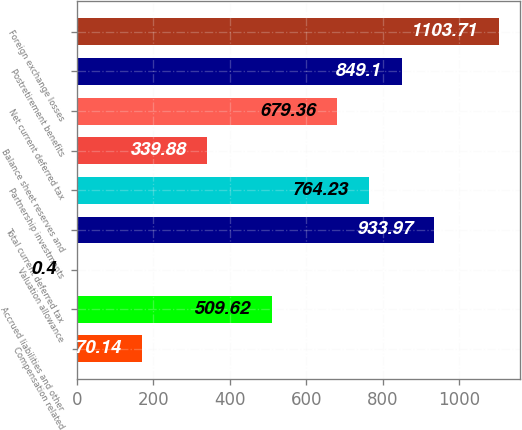Convert chart to OTSL. <chart><loc_0><loc_0><loc_500><loc_500><bar_chart><fcel>Compensation related<fcel>Accrued liabilities and other<fcel>Valuation allowance<fcel>Total current deferred tax<fcel>Partnership investments<fcel>Balance sheet reserves and<fcel>Net current deferred tax<fcel>Postretirement benefits<fcel>Foreign exchange losses<nl><fcel>170.14<fcel>509.62<fcel>0.4<fcel>933.97<fcel>764.23<fcel>339.88<fcel>679.36<fcel>849.1<fcel>1103.71<nl></chart> 